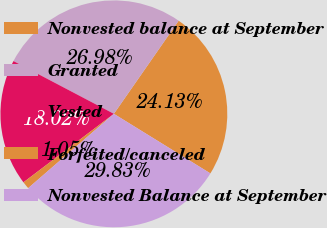Convert chart. <chart><loc_0><loc_0><loc_500><loc_500><pie_chart><fcel>Nonvested balance at September<fcel>Granted<fcel>Vested<fcel>Forfeited/canceled<fcel>Nonvested Balance at September<nl><fcel>24.13%<fcel>26.98%<fcel>18.02%<fcel>1.05%<fcel>29.83%<nl></chart> 